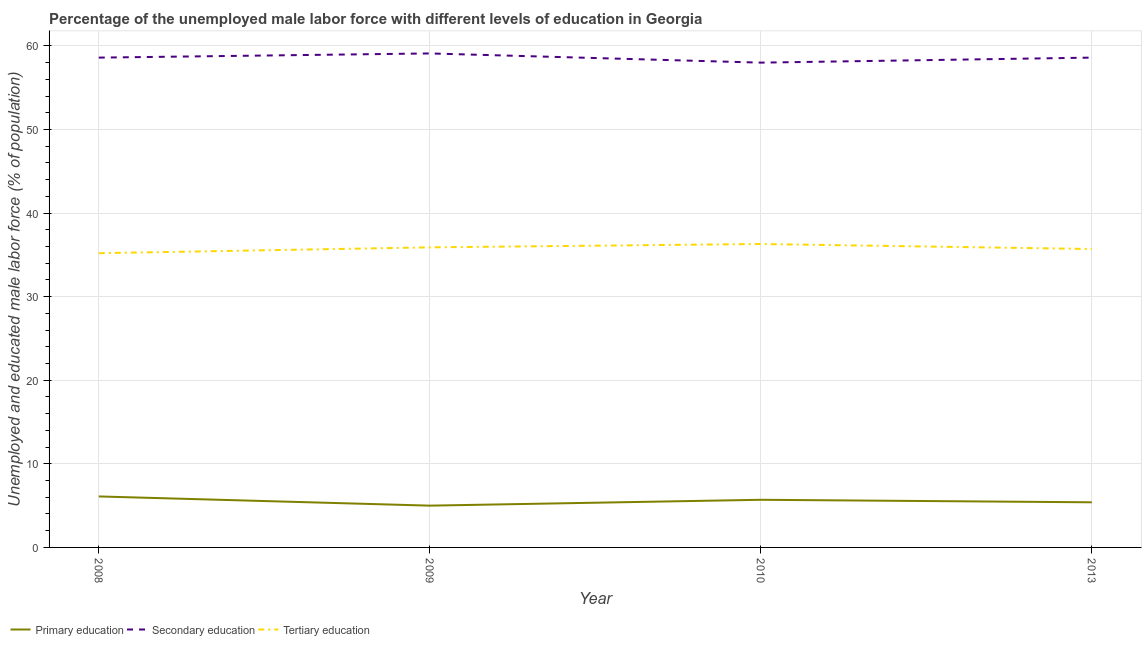How many different coloured lines are there?
Offer a very short reply. 3. What is the percentage of male labor force who received primary education in 2010?
Provide a succinct answer. 5.7. Across all years, what is the maximum percentage of male labor force who received secondary education?
Keep it short and to the point. 59.1. Across all years, what is the minimum percentage of male labor force who received primary education?
Keep it short and to the point. 5. What is the total percentage of male labor force who received primary education in the graph?
Give a very brief answer. 22.2. What is the difference between the percentage of male labor force who received primary education in 2010 and that in 2013?
Your answer should be very brief. 0.3. What is the difference between the percentage of male labor force who received primary education in 2013 and the percentage of male labor force who received tertiary education in 2010?
Your answer should be very brief. -30.9. What is the average percentage of male labor force who received primary education per year?
Your answer should be very brief. 5.55. In the year 2013, what is the difference between the percentage of male labor force who received primary education and percentage of male labor force who received secondary education?
Make the answer very short. -53.2. What is the ratio of the percentage of male labor force who received primary education in 2008 to that in 2010?
Your answer should be compact. 1.07. Is the percentage of male labor force who received tertiary education in 2010 less than that in 2013?
Ensure brevity in your answer.  No. Is the difference between the percentage of male labor force who received tertiary education in 2008 and 2009 greater than the difference between the percentage of male labor force who received primary education in 2008 and 2009?
Offer a very short reply. No. What is the difference between the highest and the second highest percentage of male labor force who received secondary education?
Offer a terse response. 0.5. What is the difference between the highest and the lowest percentage of male labor force who received primary education?
Your answer should be very brief. 1.1. In how many years, is the percentage of male labor force who received tertiary education greater than the average percentage of male labor force who received tertiary education taken over all years?
Your answer should be compact. 2. Is the sum of the percentage of male labor force who received tertiary education in 2009 and 2010 greater than the maximum percentage of male labor force who received primary education across all years?
Make the answer very short. Yes. Is it the case that in every year, the sum of the percentage of male labor force who received primary education and percentage of male labor force who received secondary education is greater than the percentage of male labor force who received tertiary education?
Your answer should be very brief. Yes. How many lines are there?
Your answer should be compact. 3. How many years are there in the graph?
Your response must be concise. 4. What is the difference between two consecutive major ticks on the Y-axis?
Provide a succinct answer. 10. Are the values on the major ticks of Y-axis written in scientific E-notation?
Keep it short and to the point. No. Does the graph contain any zero values?
Offer a very short reply. No. Does the graph contain grids?
Your answer should be compact. Yes. How many legend labels are there?
Offer a terse response. 3. What is the title of the graph?
Offer a very short reply. Percentage of the unemployed male labor force with different levels of education in Georgia. Does "Private sector" appear as one of the legend labels in the graph?
Provide a short and direct response. No. What is the label or title of the Y-axis?
Provide a succinct answer. Unemployed and educated male labor force (% of population). What is the Unemployed and educated male labor force (% of population) of Primary education in 2008?
Make the answer very short. 6.1. What is the Unemployed and educated male labor force (% of population) in Secondary education in 2008?
Give a very brief answer. 58.6. What is the Unemployed and educated male labor force (% of population) of Tertiary education in 2008?
Provide a short and direct response. 35.2. What is the Unemployed and educated male labor force (% of population) in Primary education in 2009?
Your answer should be very brief. 5. What is the Unemployed and educated male labor force (% of population) in Secondary education in 2009?
Make the answer very short. 59.1. What is the Unemployed and educated male labor force (% of population) in Tertiary education in 2009?
Offer a terse response. 35.9. What is the Unemployed and educated male labor force (% of population) in Primary education in 2010?
Keep it short and to the point. 5.7. What is the Unemployed and educated male labor force (% of population) of Tertiary education in 2010?
Keep it short and to the point. 36.3. What is the Unemployed and educated male labor force (% of population) of Primary education in 2013?
Your answer should be very brief. 5.4. What is the Unemployed and educated male labor force (% of population) in Secondary education in 2013?
Ensure brevity in your answer.  58.6. What is the Unemployed and educated male labor force (% of population) of Tertiary education in 2013?
Your answer should be compact. 35.7. Across all years, what is the maximum Unemployed and educated male labor force (% of population) in Primary education?
Ensure brevity in your answer.  6.1. Across all years, what is the maximum Unemployed and educated male labor force (% of population) of Secondary education?
Your response must be concise. 59.1. Across all years, what is the maximum Unemployed and educated male labor force (% of population) of Tertiary education?
Ensure brevity in your answer.  36.3. Across all years, what is the minimum Unemployed and educated male labor force (% of population) in Primary education?
Give a very brief answer. 5. Across all years, what is the minimum Unemployed and educated male labor force (% of population) of Tertiary education?
Your response must be concise. 35.2. What is the total Unemployed and educated male labor force (% of population) in Primary education in the graph?
Your answer should be very brief. 22.2. What is the total Unemployed and educated male labor force (% of population) of Secondary education in the graph?
Provide a succinct answer. 234.3. What is the total Unemployed and educated male labor force (% of population) in Tertiary education in the graph?
Your answer should be very brief. 143.1. What is the difference between the Unemployed and educated male labor force (% of population) in Secondary education in 2008 and that in 2009?
Give a very brief answer. -0.5. What is the difference between the Unemployed and educated male labor force (% of population) in Tertiary education in 2008 and that in 2009?
Provide a succinct answer. -0.7. What is the difference between the Unemployed and educated male labor force (% of population) in Secondary education in 2008 and that in 2010?
Give a very brief answer. 0.6. What is the difference between the Unemployed and educated male labor force (% of population) in Secondary education in 2008 and that in 2013?
Offer a very short reply. 0. What is the difference between the Unemployed and educated male labor force (% of population) in Tertiary education in 2008 and that in 2013?
Keep it short and to the point. -0.5. What is the difference between the Unemployed and educated male labor force (% of population) in Secondary education in 2009 and that in 2010?
Give a very brief answer. 1.1. What is the difference between the Unemployed and educated male labor force (% of population) in Secondary education in 2009 and that in 2013?
Provide a short and direct response. 0.5. What is the difference between the Unemployed and educated male labor force (% of population) in Tertiary education in 2009 and that in 2013?
Your response must be concise. 0.2. What is the difference between the Unemployed and educated male labor force (% of population) in Primary education in 2010 and that in 2013?
Make the answer very short. 0.3. What is the difference between the Unemployed and educated male labor force (% of population) of Secondary education in 2010 and that in 2013?
Provide a short and direct response. -0.6. What is the difference between the Unemployed and educated male labor force (% of population) in Primary education in 2008 and the Unemployed and educated male labor force (% of population) in Secondary education in 2009?
Ensure brevity in your answer.  -53. What is the difference between the Unemployed and educated male labor force (% of population) of Primary education in 2008 and the Unemployed and educated male labor force (% of population) of Tertiary education in 2009?
Provide a succinct answer. -29.8. What is the difference between the Unemployed and educated male labor force (% of population) in Secondary education in 2008 and the Unemployed and educated male labor force (% of population) in Tertiary education in 2009?
Your response must be concise. 22.7. What is the difference between the Unemployed and educated male labor force (% of population) in Primary education in 2008 and the Unemployed and educated male labor force (% of population) in Secondary education in 2010?
Make the answer very short. -51.9. What is the difference between the Unemployed and educated male labor force (% of population) of Primary education in 2008 and the Unemployed and educated male labor force (% of population) of Tertiary education in 2010?
Give a very brief answer. -30.2. What is the difference between the Unemployed and educated male labor force (% of population) in Secondary education in 2008 and the Unemployed and educated male labor force (% of population) in Tertiary education in 2010?
Provide a succinct answer. 22.3. What is the difference between the Unemployed and educated male labor force (% of population) of Primary education in 2008 and the Unemployed and educated male labor force (% of population) of Secondary education in 2013?
Keep it short and to the point. -52.5. What is the difference between the Unemployed and educated male labor force (% of population) in Primary education in 2008 and the Unemployed and educated male labor force (% of population) in Tertiary education in 2013?
Make the answer very short. -29.6. What is the difference between the Unemployed and educated male labor force (% of population) of Secondary education in 2008 and the Unemployed and educated male labor force (% of population) of Tertiary education in 2013?
Ensure brevity in your answer.  22.9. What is the difference between the Unemployed and educated male labor force (% of population) of Primary education in 2009 and the Unemployed and educated male labor force (% of population) of Secondary education in 2010?
Keep it short and to the point. -53. What is the difference between the Unemployed and educated male labor force (% of population) in Primary education in 2009 and the Unemployed and educated male labor force (% of population) in Tertiary education in 2010?
Ensure brevity in your answer.  -31.3. What is the difference between the Unemployed and educated male labor force (% of population) in Secondary education in 2009 and the Unemployed and educated male labor force (% of population) in Tertiary education in 2010?
Your answer should be compact. 22.8. What is the difference between the Unemployed and educated male labor force (% of population) of Primary education in 2009 and the Unemployed and educated male labor force (% of population) of Secondary education in 2013?
Keep it short and to the point. -53.6. What is the difference between the Unemployed and educated male labor force (% of population) of Primary education in 2009 and the Unemployed and educated male labor force (% of population) of Tertiary education in 2013?
Your response must be concise. -30.7. What is the difference between the Unemployed and educated male labor force (% of population) in Secondary education in 2009 and the Unemployed and educated male labor force (% of population) in Tertiary education in 2013?
Your answer should be very brief. 23.4. What is the difference between the Unemployed and educated male labor force (% of population) in Primary education in 2010 and the Unemployed and educated male labor force (% of population) in Secondary education in 2013?
Offer a very short reply. -52.9. What is the difference between the Unemployed and educated male labor force (% of population) in Secondary education in 2010 and the Unemployed and educated male labor force (% of population) in Tertiary education in 2013?
Your answer should be very brief. 22.3. What is the average Unemployed and educated male labor force (% of population) in Primary education per year?
Give a very brief answer. 5.55. What is the average Unemployed and educated male labor force (% of population) of Secondary education per year?
Your answer should be very brief. 58.58. What is the average Unemployed and educated male labor force (% of population) in Tertiary education per year?
Your answer should be compact. 35.77. In the year 2008, what is the difference between the Unemployed and educated male labor force (% of population) of Primary education and Unemployed and educated male labor force (% of population) of Secondary education?
Your response must be concise. -52.5. In the year 2008, what is the difference between the Unemployed and educated male labor force (% of population) in Primary education and Unemployed and educated male labor force (% of population) in Tertiary education?
Provide a succinct answer. -29.1. In the year 2008, what is the difference between the Unemployed and educated male labor force (% of population) in Secondary education and Unemployed and educated male labor force (% of population) in Tertiary education?
Keep it short and to the point. 23.4. In the year 2009, what is the difference between the Unemployed and educated male labor force (% of population) in Primary education and Unemployed and educated male labor force (% of population) in Secondary education?
Your response must be concise. -54.1. In the year 2009, what is the difference between the Unemployed and educated male labor force (% of population) of Primary education and Unemployed and educated male labor force (% of population) of Tertiary education?
Ensure brevity in your answer.  -30.9. In the year 2009, what is the difference between the Unemployed and educated male labor force (% of population) of Secondary education and Unemployed and educated male labor force (% of population) of Tertiary education?
Provide a succinct answer. 23.2. In the year 2010, what is the difference between the Unemployed and educated male labor force (% of population) of Primary education and Unemployed and educated male labor force (% of population) of Secondary education?
Your response must be concise. -52.3. In the year 2010, what is the difference between the Unemployed and educated male labor force (% of population) of Primary education and Unemployed and educated male labor force (% of population) of Tertiary education?
Offer a terse response. -30.6. In the year 2010, what is the difference between the Unemployed and educated male labor force (% of population) of Secondary education and Unemployed and educated male labor force (% of population) of Tertiary education?
Give a very brief answer. 21.7. In the year 2013, what is the difference between the Unemployed and educated male labor force (% of population) in Primary education and Unemployed and educated male labor force (% of population) in Secondary education?
Provide a succinct answer. -53.2. In the year 2013, what is the difference between the Unemployed and educated male labor force (% of population) of Primary education and Unemployed and educated male labor force (% of population) of Tertiary education?
Ensure brevity in your answer.  -30.3. In the year 2013, what is the difference between the Unemployed and educated male labor force (% of population) in Secondary education and Unemployed and educated male labor force (% of population) in Tertiary education?
Offer a terse response. 22.9. What is the ratio of the Unemployed and educated male labor force (% of population) in Primary education in 2008 to that in 2009?
Your response must be concise. 1.22. What is the ratio of the Unemployed and educated male labor force (% of population) in Tertiary education in 2008 to that in 2009?
Provide a short and direct response. 0.98. What is the ratio of the Unemployed and educated male labor force (% of population) in Primary education in 2008 to that in 2010?
Give a very brief answer. 1.07. What is the ratio of the Unemployed and educated male labor force (% of population) in Secondary education in 2008 to that in 2010?
Provide a short and direct response. 1.01. What is the ratio of the Unemployed and educated male labor force (% of population) of Tertiary education in 2008 to that in 2010?
Ensure brevity in your answer.  0.97. What is the ratio of the Unemployed and educated male labor force (% of population) in Primary education in 2008 to that in 2013?
Offer a very short reply. 1.13. What is the ratio of the Unemployed and educated male labor force (% of population) of Tertiary education in 2008 to that in 2013?
Ensure brevity in your answer.  0.99. What is the ratio of the Unemployed and educated male labor force (% of population) of Primary education in 2009 to that in 2010?
Provide a succinct answer. 0.88. What is the ratio of the Unemployed and educated male labor force (% of population) in Tertiary education in 2009 to that in 2010?
Your answer should be compact. 0.99. What is the ratio of the Unemployed and educated male labor force (% of population) of Primary education in 2009 to that in 2013?
Your answer should be very brief. 0.93. What is the ratio of the Unemployed and educated male labor force (% of population) of Secondary education in 2009 to that in 2013?
Your response must be concise. 1.01. What is the ratio of the Unemployed and educated male labor force (% of population) in Tertiary education in 2009 to that in 2013?
Your answer should be very brief. 1.01. What is the ratio of the Unemployed and educated male labor force (% of population) in Primary education in 2010 to that in 2013?
Provide a short and direct response. 1.06. What is the ratio of the Unemployed and educated male labor force (% of population) in Tertiary education in 2010 to that in 2013?
Offer a very short reply. 1.02. What is the difference between the highest and the lowest Unemployed and educated male labor force (% of population) in Primary education?
Give a very brief answer. 1.1. 